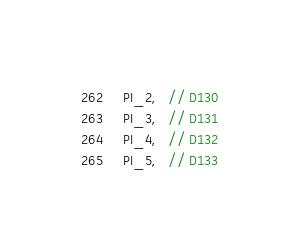<code> <loc_0><loc_0><loc_500><loc_500><_C++_>  PI_2,   // D130
  PI_3,   // D131
  PI_4,   // D132
  PI_5,   // D133</code> 